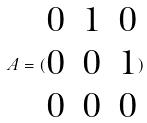Convert formula to latex. <formula><loc_0><loc_0><loc_500><loc_500>A = ( \begin{matrix} 0 & 1 & 0 \\ 0 & 0 & 1 \\ 0 & 0 & 0 \end{matrix} )</formula> 